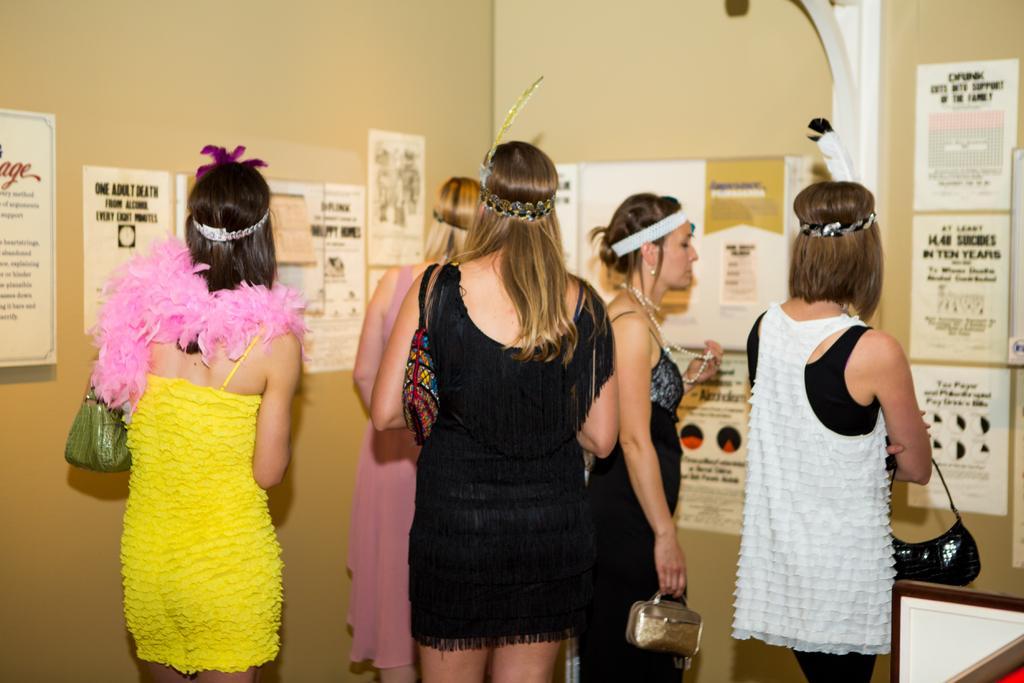Describe this image in one or two sentences. In this image I can see the group of people with different color dresses. I can see four people are holding the bags. In-front of these people I can see many boards to the cream color wall. 